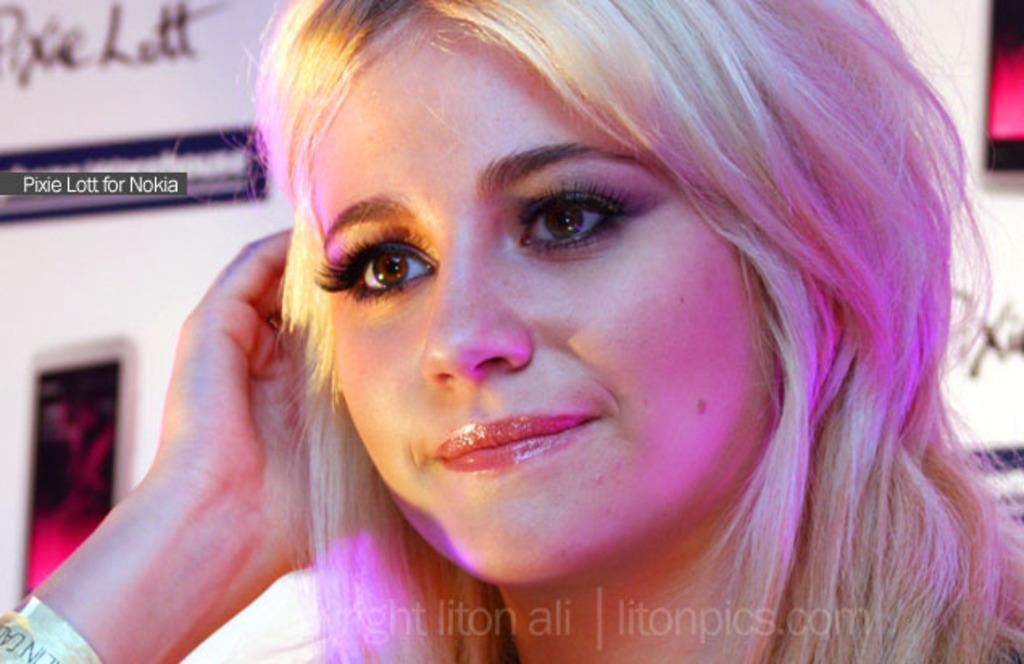Who is present in the image? There is a woman in the picture. What can be seen in the background of the image? There is a banner in the background of the picture. How much does the smoke weigh in the image? There is no smoke present in the image, so it is not possible to determine its weight. 